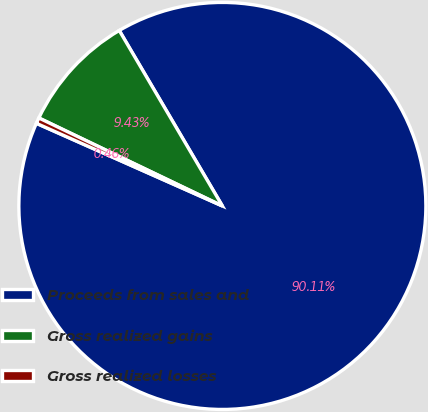<chart> <loc_0><loc_0><loc_500><loc_500><pie_chart><fcel>Proceeds from sales and<fcel>Gross realized gains<fcel>Gross realized losses<nl><fcel>90.11%<fcel>9.43%<fcel>0.46%<nl></chart> 